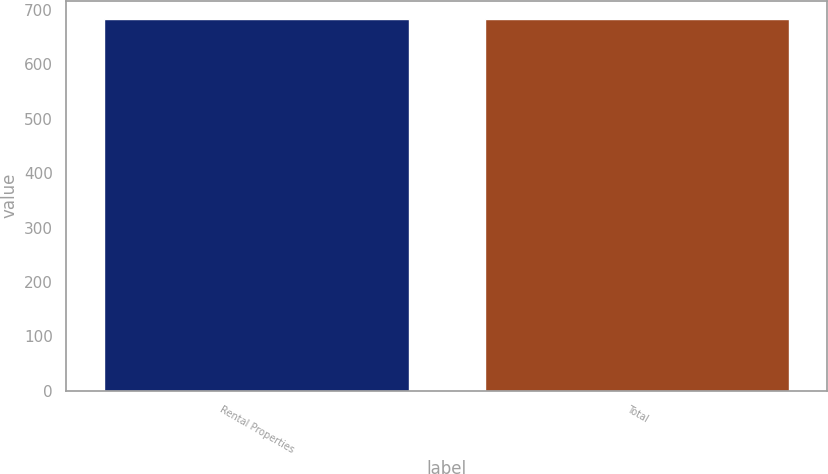Convert chart. <chart><loc_0><loc_0><loc_500><loc_500><bar_chart><fcel>Rental Properties<fcel>Total<nl><fcel>683<fcel>683.1<nl></chart> 